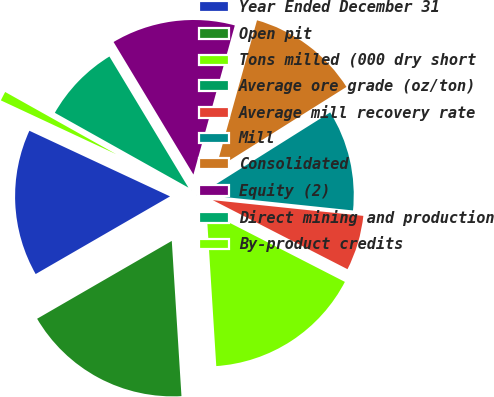Convert chart to OTSL. <chart><loc_0><loc_0><loc_500><loc_500><pie_chart><fcel>Year Ended December 31<fcel>Open pit<fcel>Tons milled (000 dry short<fcel>Average ore grade (oz/ton)<fcel>Average mill recovery rate<fcel>Mill<fcel>Consolidated<fcel>Equity (2)<fcel>Direct mining and production<fcel>By-product credits<nl><fcel>15.29%<fcel>17.65%<fcel>16.47%<fcel>0.0%<fcel>5.88%<fcel>10.59%<fcel>11.76%<fcel>12.94%<fcel>8.24%<fcel>1.18%<nl></chart> 